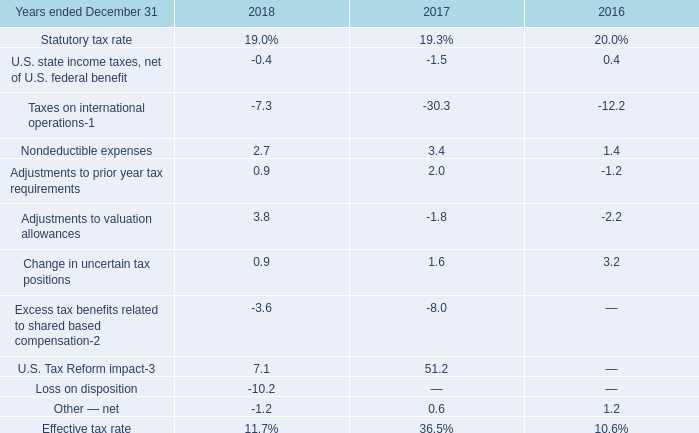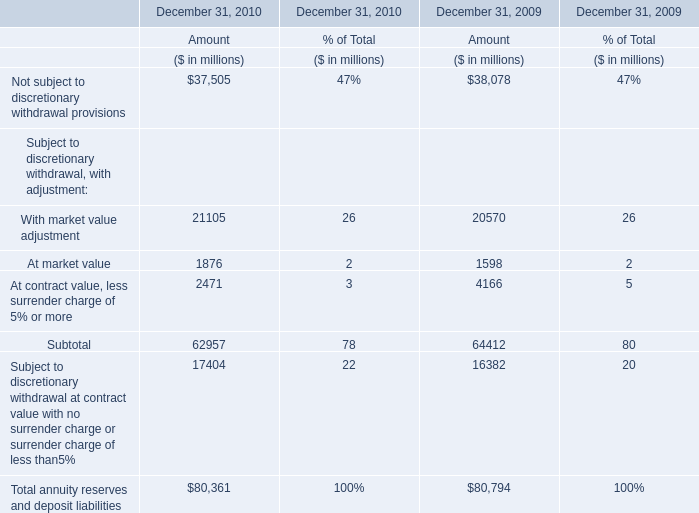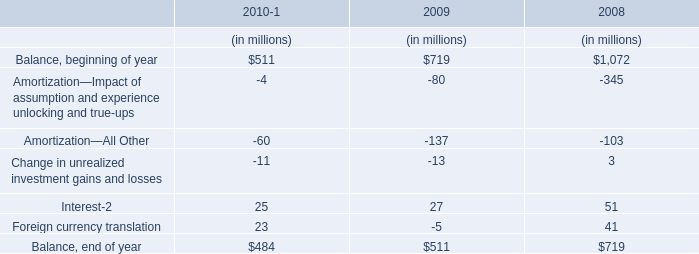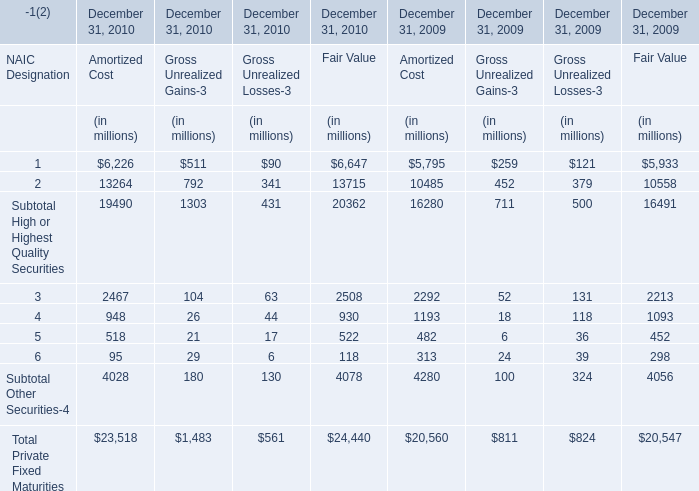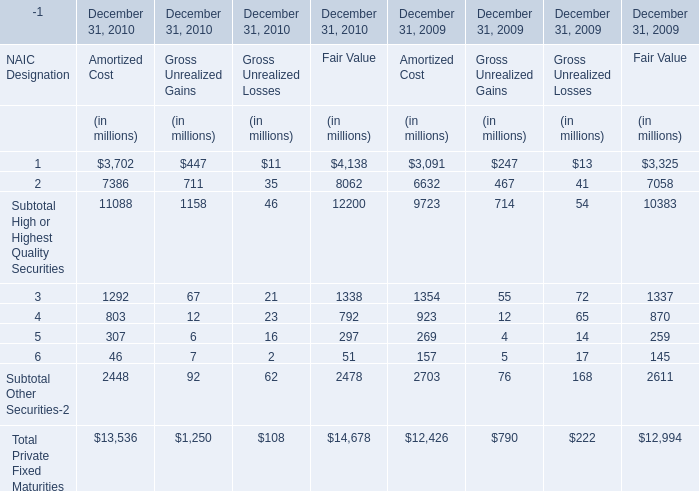In what year is Subtotal High or Highest Quality Securities greater than 2000 for Amortized Cost? 
Answer: 2009 2010. 